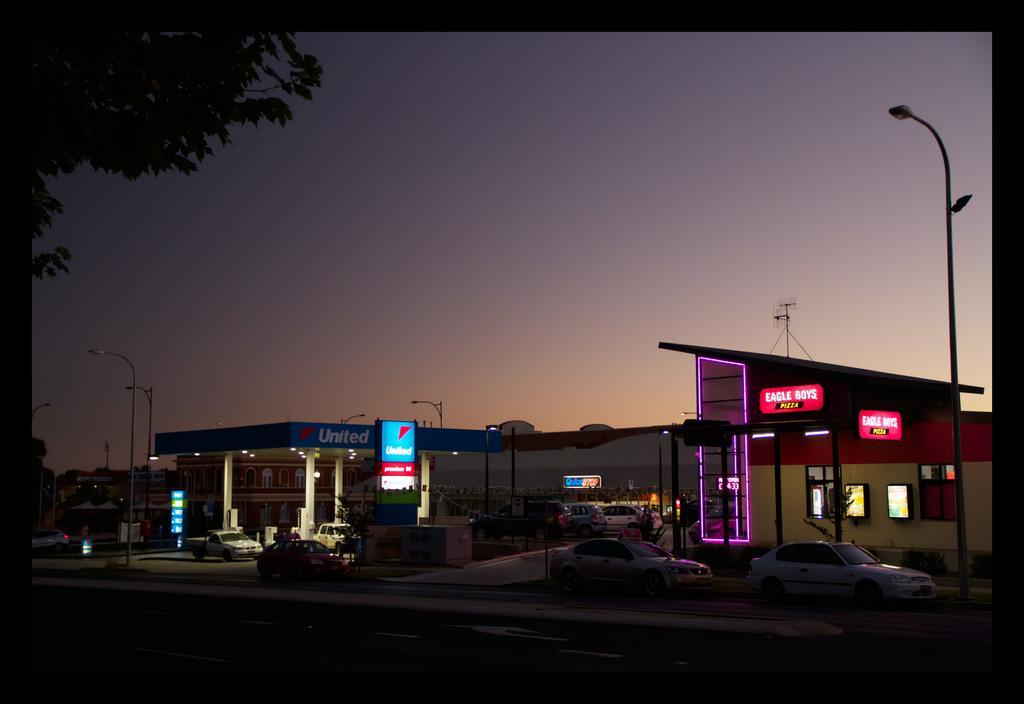Describe this image in one or two sentences. In this image there is a petrol bunk, buildings, vehicles, light poles, hoardings, board, tree, sky and objects. Something is written on the boards and hoarding. 